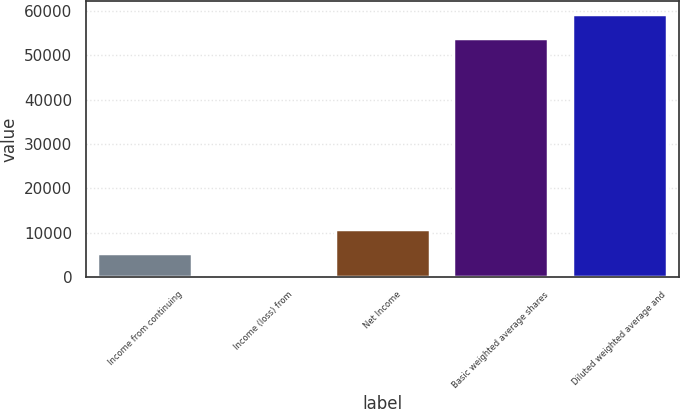<chart> <loc_0><loc_0><loc_500><loc_500><bar_chart><fcel>Income from continuing<fcel>Income (loss) from<fcel>Net Income<fcel>Basic weighted average shares<fcel>Diluted weighted average and<nl><fcel>5419.84<fcel>0.82<fcel>10838.9<fcel>53854<fcel>59273<nl></chart> 